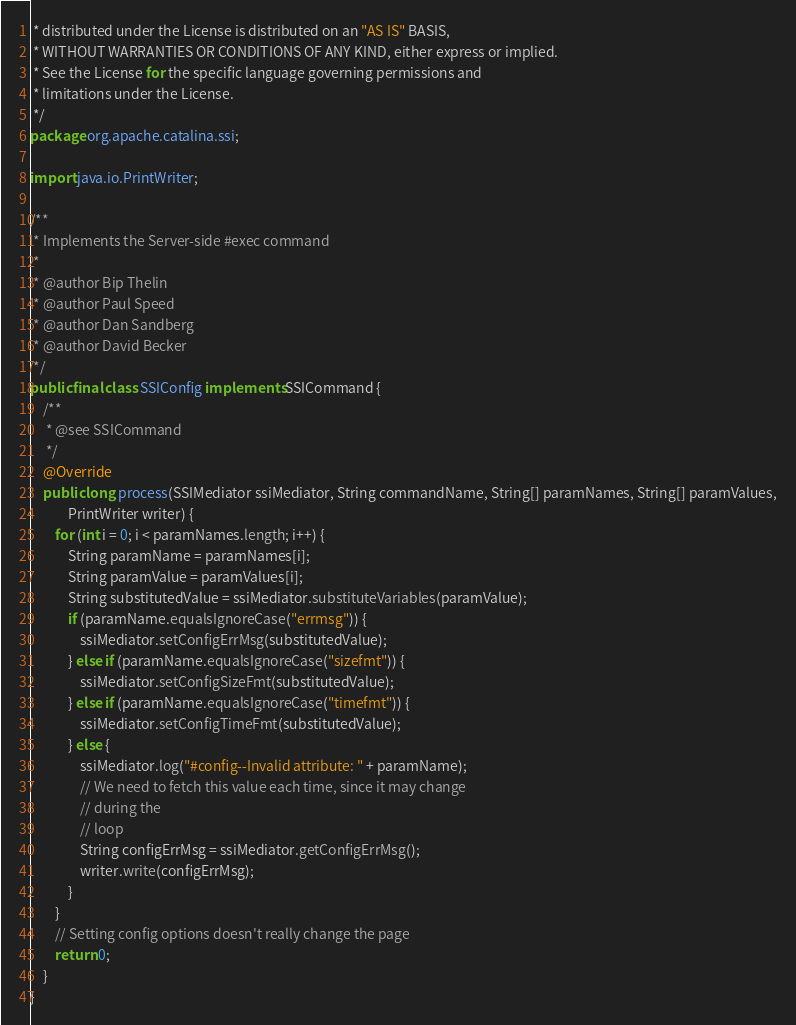<code> <loc_0><loc_0><loc_500><loc_500><_Java_> * distributed under the License is distributed on an "AS IS" BASIS,
 * WITHOUT WARRANTIES OR CONDITIONS OF ANY KIND, either express or implied.
 * See the License for the specific language governing permissions and
 * limitations under the License.
 */
package org.apache.catalina.ssi;

import java.io.PrintWriter;

/**
 * Implements the Server-side #exec command
 * 
 * @author Bip Thelin
 * @author Paul Speed
 * @author Dan Sandberg
 * @author David Becker
 */
public final class SSIConfig implements SSICommand {
	/**
	 * @see SSICommand
	 */
	@Override
	public long process(SSIMediator ssiMediator, String commandName, String[] paramNames, String[] paramValues,
			PrintWriter writer) {
		for (int i = 0; i < paramNames.length; i++) {
			String paramName = paramNames[i];
			String paramValue = paramValues[i];
			String substitutedValue = ssiMediator.substituteVariables(paramValue);
			if (paramName.equalsIgnoreCase("errmsg")) {
				ssiMediator.setConfigErrMsg(substitutedValue);
			} else if (paramName.equalsIgnoreCase("sizefmt")) {
				ssiMediator.setConfigSizeFmt(substitutedValue);
			} else if (paramName.equalsIgnoreCase("timefmt")) {
				ssiMediator.setConfigTimeFmt(substitutedValue);
			} else {
				ssiMediator.log("#config--Invalid attribute: " + paramName);
				// We need to fetch this value each time, since it may change
				// during the
				// loop
				String configErrMsg = ssiMediator.getConfigErrMsg();
				writer.write(configErrMsg);
			}
		}
		// Setting config options doesn't really change the page
		return 0;
	}
}</code> 